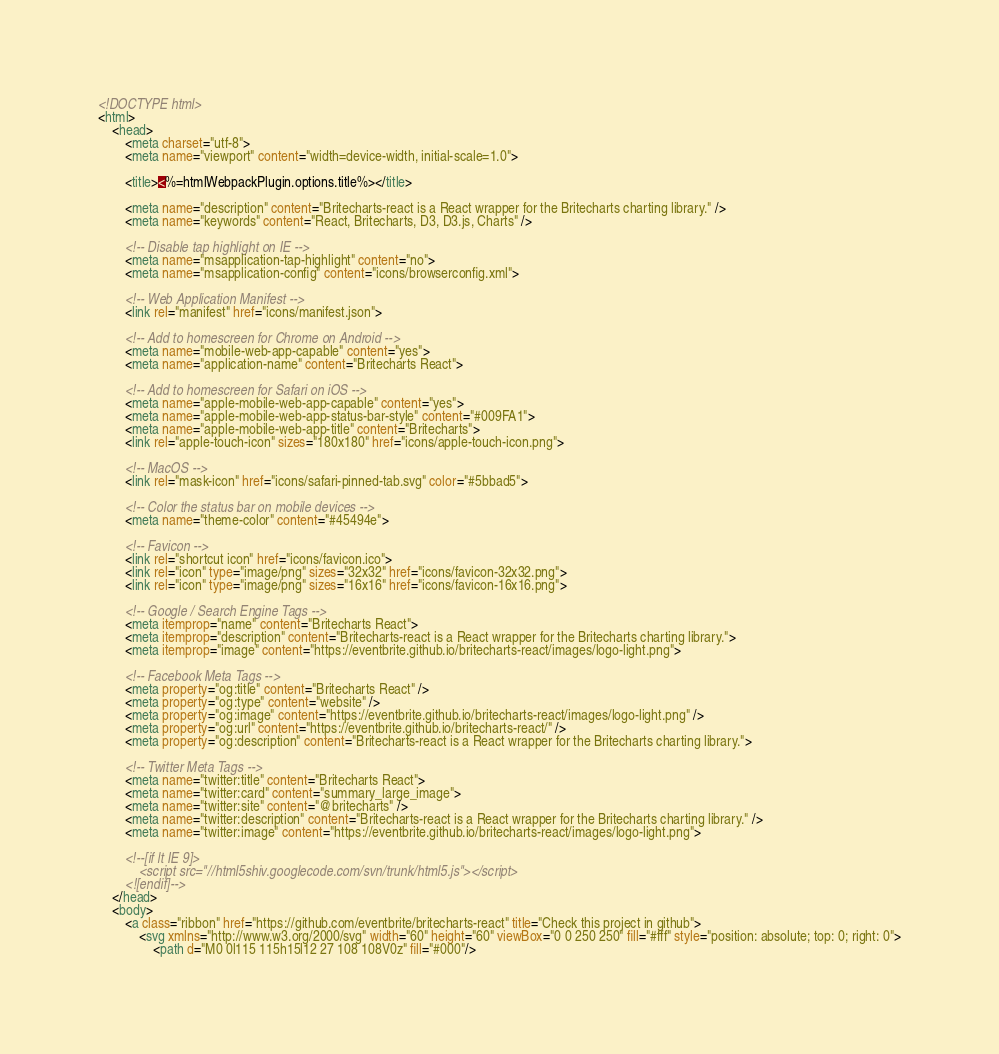Convert code to text. <code><loc_0><loc_0><loc_500><loc_500><_HTML_><!DOCTYPE html>
<html>
    <head>
        <meta charset="utf-8">
        <meta name="viewport" content="width=device-width, initial-scale=1.0">

        <title><%=htmlWebpackPlugin.options.title%></title>

        <meta name="description" content="Britecharts-react is a React wrapper for the Britecharts charting library." />
        <meta name="keywords" content="React, Britecharts, D3, D3.js, Charts" />

        <!-- Disable tap highlight on IE -->
        <meta name="msapplication-tap-highlight" content="no">
        <meta name="msapplication-config" content="icons/browserconfig.xml">

        <!-- Web Application Manifest -->
        <link rel="manifest" href="icons/manifest.json">

        <!-- Add to homescreen for Chrome on Android -->
        <meta name="mobile-web-app-capable" content="yes">
        <meta name="application-name" content="Britecharts React">

        <!-- Add to homescreen for Safari on iOS -->
        <meta name="apple-mobile-web-app-capable" content="yes">
        <meta name="apple-mobile-web-app-status-bar-style" content="#009FA1">
        <meta name="apple-mobile-web-app-title" content="Britecharts">
        <link rel="apple-touch-icon" sizes="180x180" href="icons/apple-touch-icon.png">

        <!-- MacOS -->
        <link rel="mask-icon" href="icons/safari-pinned-tab.svg" color="#5bbad5">

        <!-- Color the status bar on mobile devices -->
        <meta name="theme-color" content="#45494e">

        <!-- Favicon -->
        <link rel="shortcut icon" href="icons/favicon.ico">
        <link rel="icon" type="image/png" sizes="32x32" href="icons/favicon-32x32.png">
        <link rel="icon" type="image/png" sizes="16x16" href="icons/favicon-16x16.png">

        <!-- Google / Search Engine Tags -->
        <meta itemprop="name" content="Britecharts React">
        <meta itemprop="description" content="Britecharts-react is a React wrapper for the Britecharts charting library.">
        <meta itemprop="image" content="https://eventbrite.github.io/britecharts-react/images/logo-light.png">

        <!-- Facebook Meta Tags -->
        <meta property="og:title" content="Britecharts React" />
        <meta property="og:type" content="website" />
        <meta property="og:image" content="https://eventbrite.github.io/britecharts-react/images/logo-light.png" />
        <meta property="og:url" content="https://eventbrite.github.io/britecharts-react/" />
        <meta property="og:description" content="Britecharts-react is a React wrapper for the Britecharts charting library.">

        <!-- Twitter Meta Tags -->
        <meta name="twitter:title" content="Britecharts React">
        <meta name="twitter:card" content="summary_large_image">
        <meta name="twitter:site" content="@britecharts" />
        <meta name="twitter:description" content="Britecharts-react is a React wrapper for the Britecharts charting library." />
        <meta name="twitter:image" content="https://eventbrite.github.io/britecharts-react/images/logo-light.png">

        <!--[if lt IE 9]>
            <script src="//html5shiv.googlecode.com/svn/trunk/html5.js"></script>
        <![endif]-->
    </head>
    <body>
        <a class="ribbon" href="https://github.com/eventbrite/britecharts-react" title="Check this project in github">
            <svg xmlns="http://www.w3.org/2000/svg" width="60" height="60" viewBox="0 0 250 250" fill="#fff" style="position: absolute; top: 0; right: 0">
                <path d="M0 0l115 115h15l12 27 108 108V0z" fill="#000"/></code> 